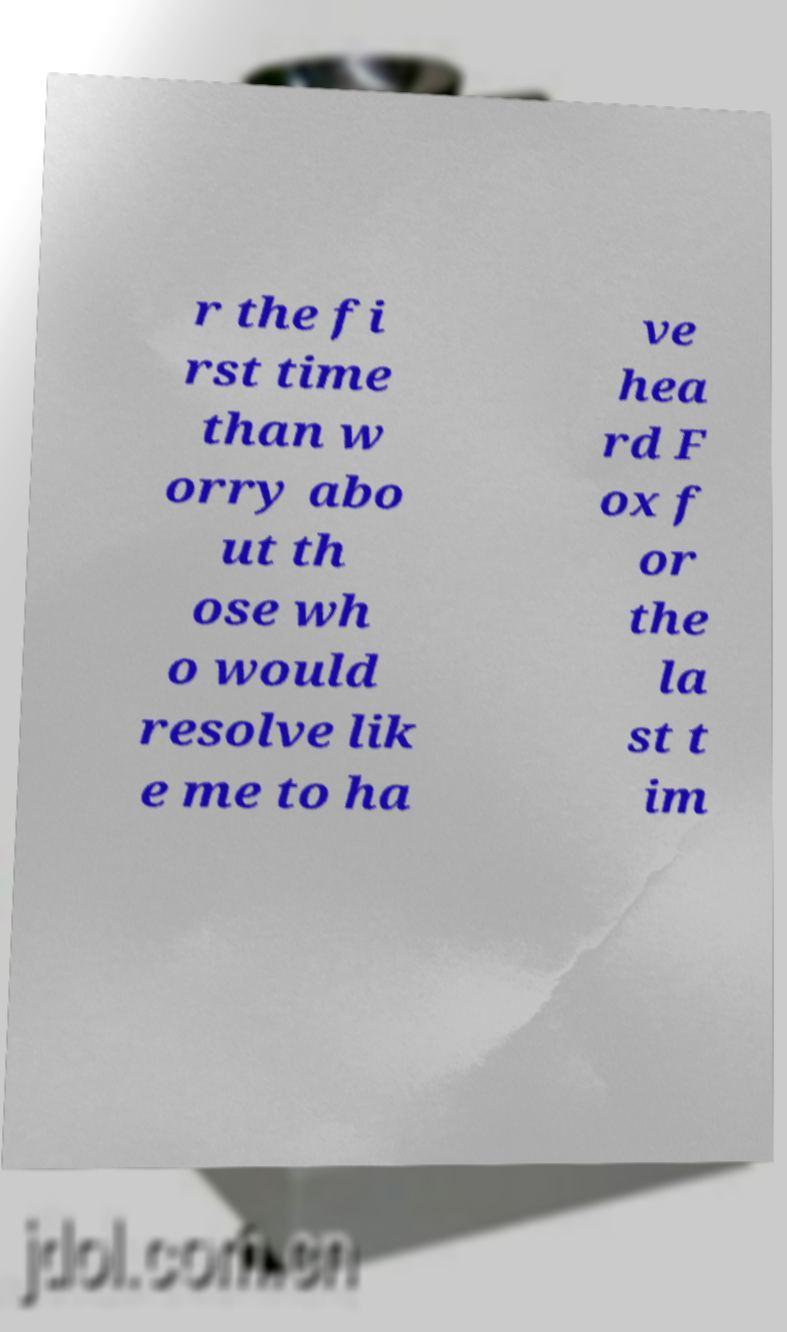Can you read and provide the text displayed in the image?This photo seems to have some interesting text. Can you extract and type it out for me? r the fi rst time than w orry abo ut th ose wh o would resolve lik e me to ha ve hea rd F ox f or the la st t im 